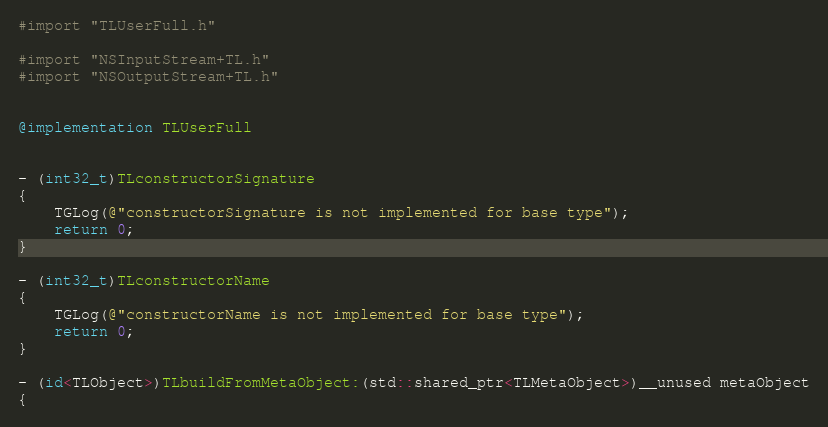Convert code to text. <code><loc_0><loc_0><loc_500><loc_500><_ObjectiveC_>#import "TLUserFull.h"

#import "NSInputStream+TL.h"
#import "NSOutputStream+TL.h"


@implementation TLUserFull


- (int32_t)TLconstructorSignature
{
    TGLog(@"constructorSignature is not implemented for base type");
    return 0;
}

- (int32_t)TLconstructorName
{
    TGLog(@"constructorName is not implemented for base type");
    return 0;
}

- (id<TLObject>)TLbuildFromMetaObject:(std::shared_ptr<TLMetaObject>)__unused metaObject
{</code> 